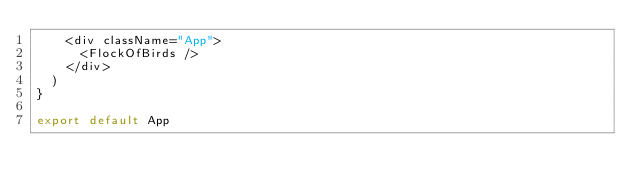Convert code to text. <code><loc_0><loc_0><loc_500><loc_500><_JavaScript_>    <div className="App">
      <FlockOfBirds />
    </div>
  )
}

export default App
</code> 